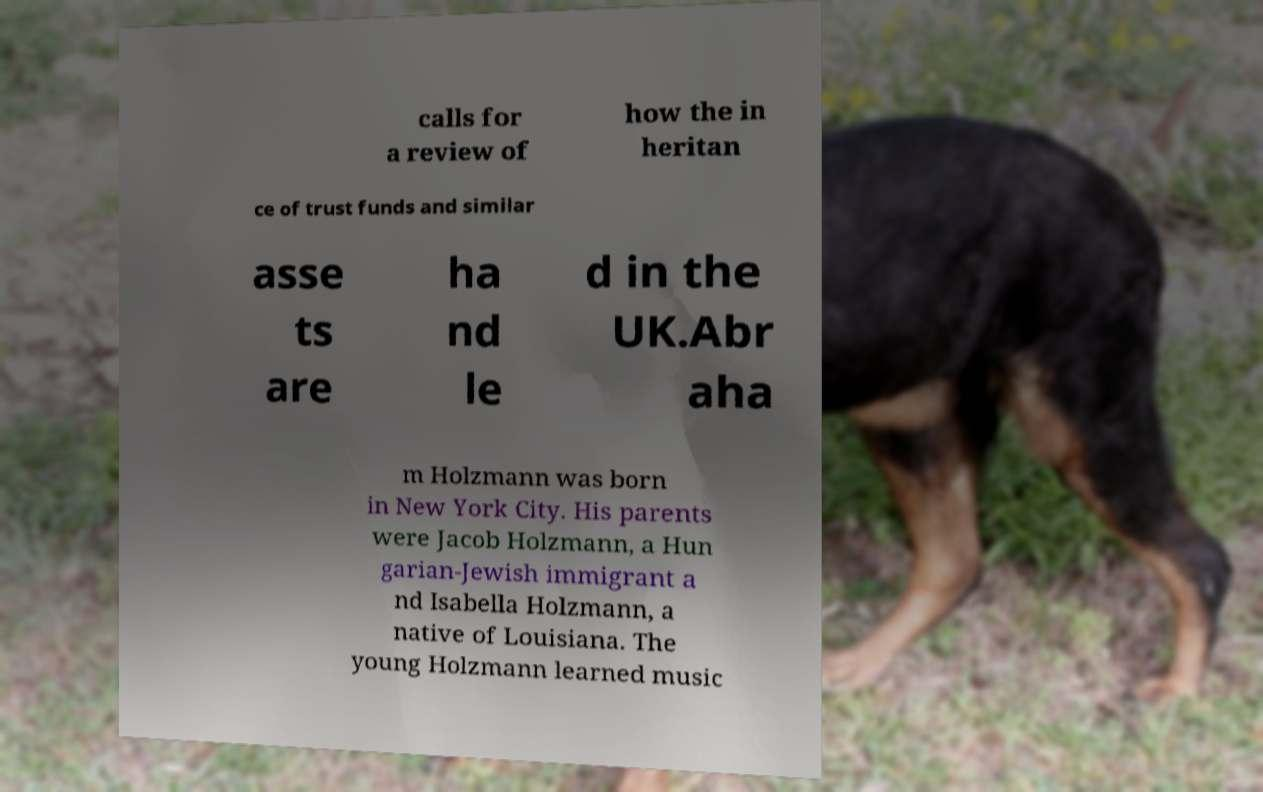There's text embedded in this image that I need extracted. Can you transcribe it verbatim? calls for a review of how the in heritan ce of trust funds and similar asse ts are ha nd le d in the UK.Abr aha m Holzmann was born in New York City. His parents were Jacob Holzmann, a Hun garian-Jewish immigrant a nd Isabella Holzmann, a native of Louisiana. The young Holzmann learned music 